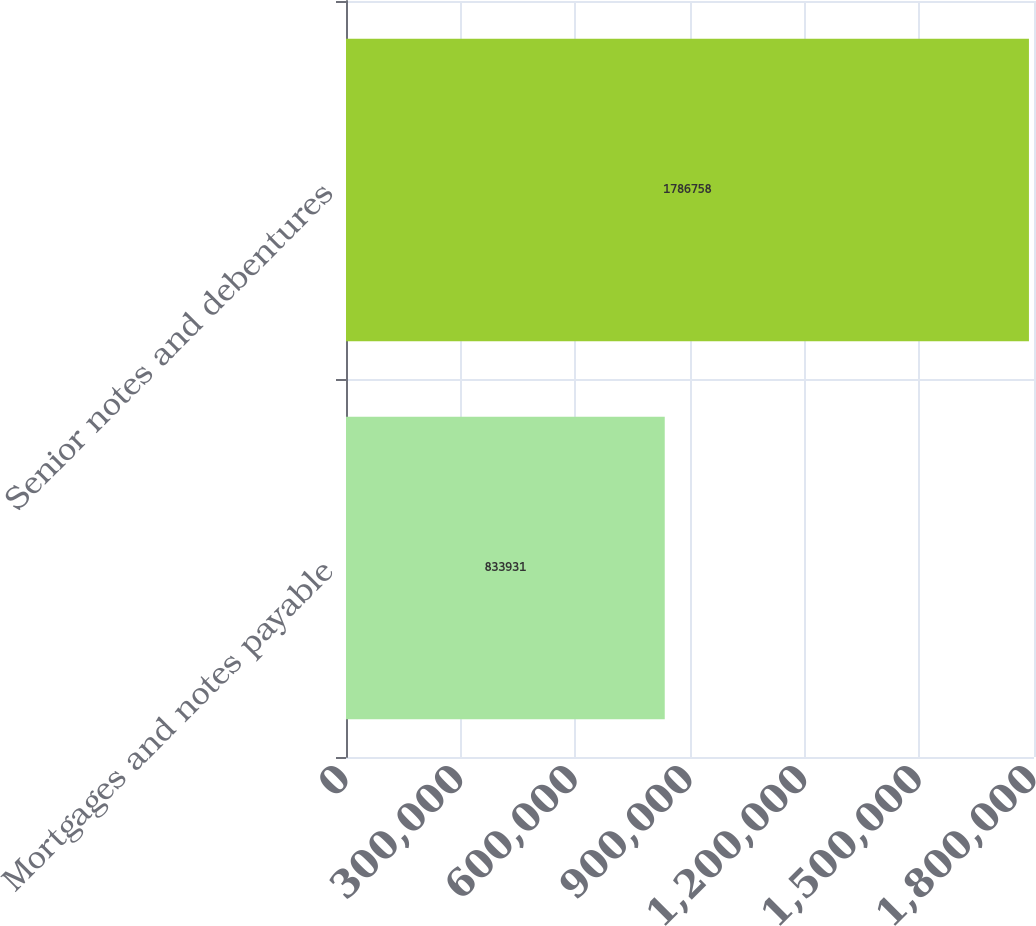Convert chart. <chart><loc_0><loc_0><loc_500><loc_500><bar_chart><fcel>Mortgages and notes payable<fcel>Senior notes and debentures<nl><fcel>833931<fcel>1.78676e+06<nl></chart> 